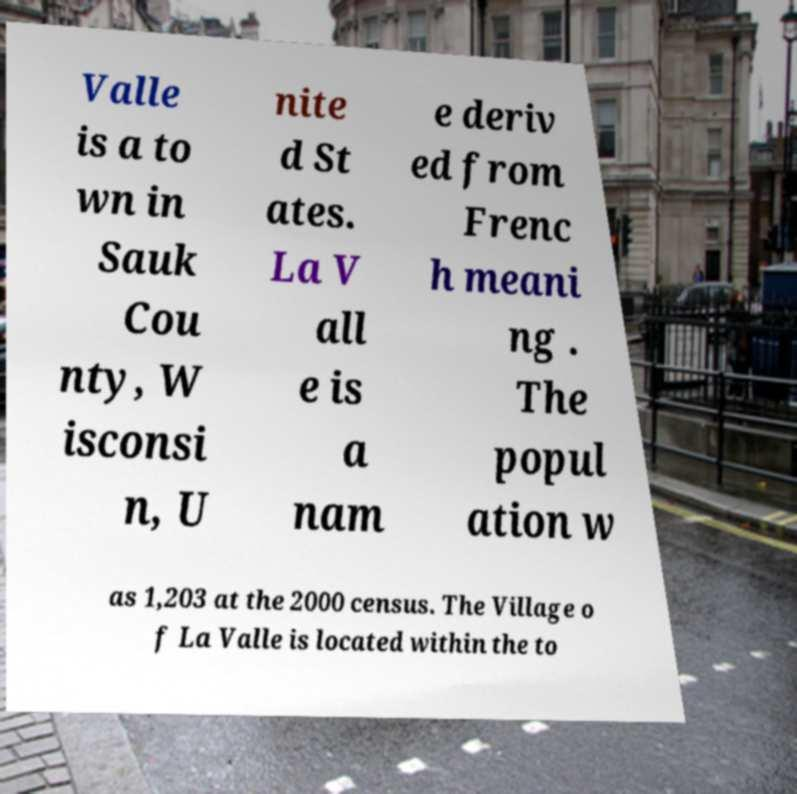Could you extract and type out the text from this image? Valle is a to wn in Sauk Cou nty, W isconsi n, U nite d St ates. La V all e is a nam e deriv ed from Frenc h meani ng . The popul ation w as 1,203 at the 2000 census. The Village o f La Valle is located within the to 